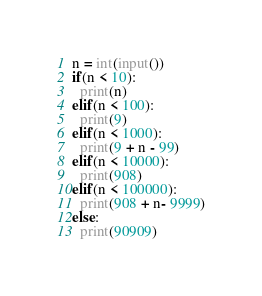Convert code to text. <code><loc_0><loc_0><loc_500><loc_500><_Python_>n = int(input())
if(n < 10):
  print(n)
elif(n < 100):
  print(9)
elif(n < 1000):
  print(9 + n - 99)
elif(n < 10000):
  print(908)
elif(n < 100000):
  print(908 + n- 9999)
else:
  print(90909)</code> 